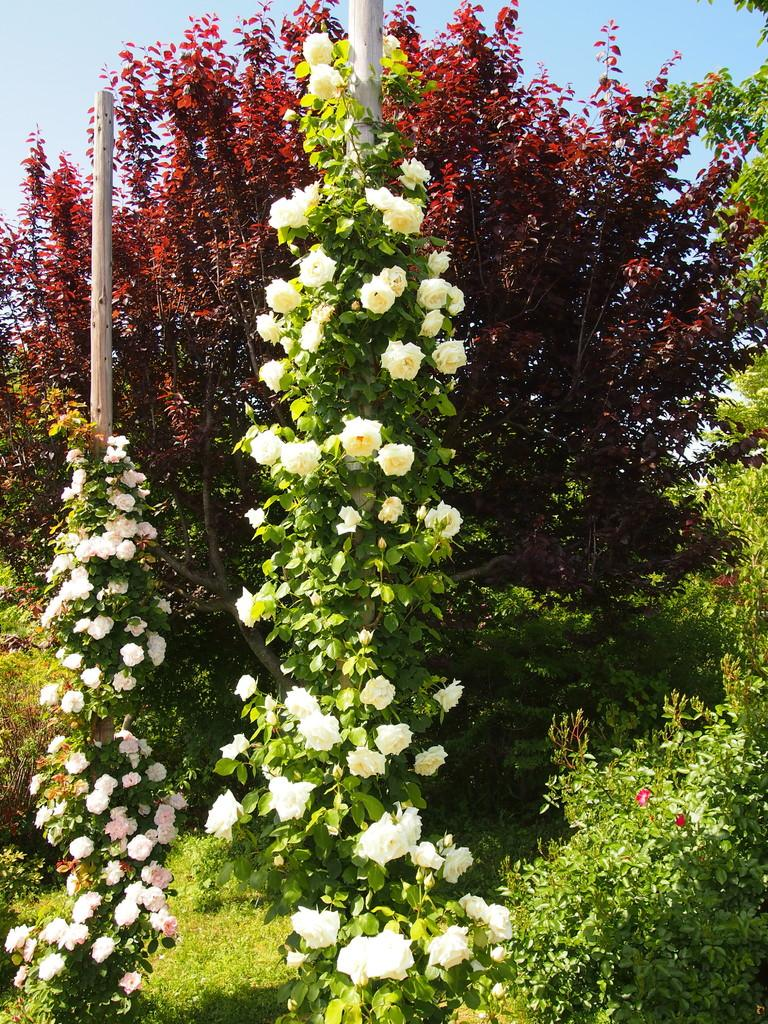What type of living organisms can be seen in the image? There are flowers in the image. Where are the flowers located? The flowers are on plants. What colors can be seen in the flowers? The flowers are in pink, white, red, and cream colors. What can be seen in the background of the image? There is a pole, a red color plant, and the sky visible in the background of the image. Can you tell me how many deer are smashing the system in the image? There are no deer or systems present in the image; it features flowers on plants with a background of a pole, a red color plant, and the sky. 